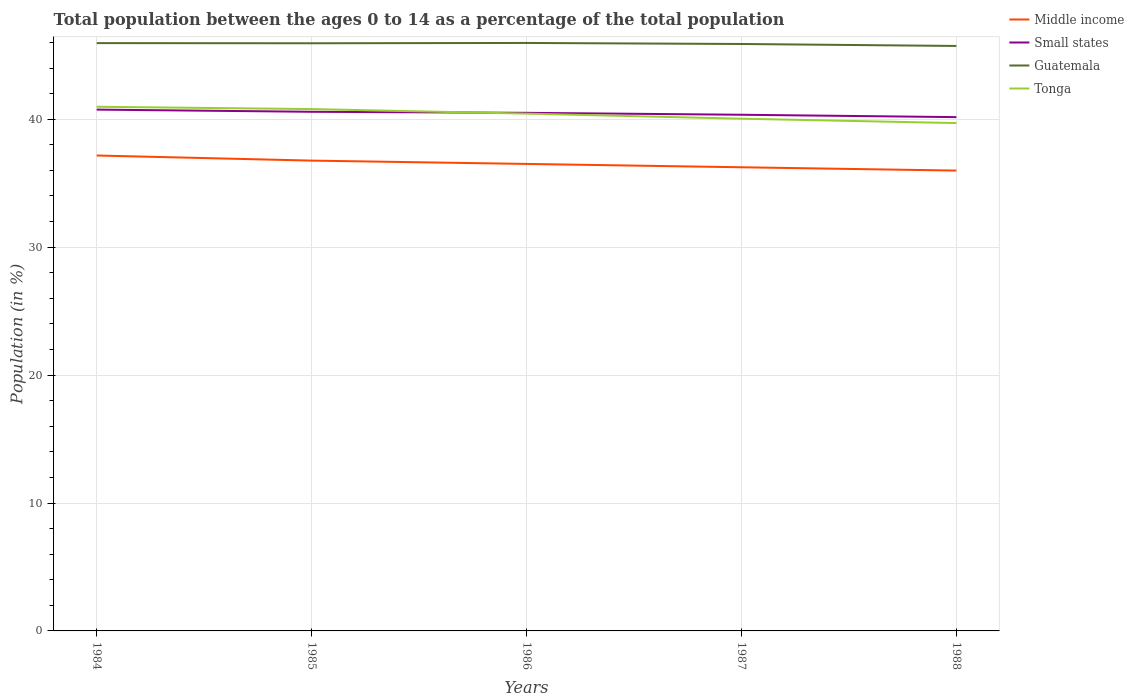Does the line corresponding to Middle income intersect with the line corresponding to Small states?
Your answer should be very brief. No. Is the number of lines equal to the number of legend labels?
Offer a very short reply. Yes. Across all years, what is the maximum percentage of the population ages 0 to 14 in Tonga?
Your response must be concise. 39.7. In which year was the percentage of the population ages 0 to 14 in Guatemala maximum?
Offer a terse response. 1988. What is the total percentage of the population ages 0 to 14 in Small states in the graph?
Give a very brief answer. 0.23. What is the difference between the highest and the second highest percentage of the population ages 0 to 14 in Small states?
Keep it short and to the point. 0.59. Is the percentage of the population ages 0 to 14 in Tonga strictly greater than the percentage of the population ages 0 to 14 in Small states over the years?
Your answer should be very brief. No. What is the difference between two consecutive major ticks on the Y-axis?
Offer a very short reply. 10. Does the graph contain any zero values?
Keep it short and to the point. No. Where does the legend appear in the graph?
Offer a very short reply. Top right. How are the legend labels stacked?
Your answer should be very brief. Vertical. What is the title of the graph?
Offer a terse response. Total population between the ages 0 to 14 as a percentage of the total population. Does "Malawi" appear as one of the legend labels in the graph?
Keep it short and to the point. No. What is the label or title of the X-axis?
Make the answer very short. Years. What is the Population (in %) in Middle income in 1984?
Your answer should be very brief. 37.17. What is the Population (in %) in Small states in 1984?
Your response must be concise. 40.75. What is the Population (in %) of Guatemala in 1984?
Your answer should be very brief. 45.95. What is the Population (in %) of Tonga in 1984?
Give a very brief answer. 40.98. What is the Population (in %) in Middle income in 1985?
Give a very brief answer. 36.77. What is the Population (in %) of Small states in 1985?
Keep it short and to the point. 40.58. What is the Population (in %) of Guatemala in 1985?
Your answer should be compact. 45.94. What is the Population (in %) of Tonga in 1985?
Your response must be concise. 40.79. What is the Population (in %) in Middle income in 1986?
Your response must be concise. 36.51. What is the Population (in %) of Small states in 1986?
Offer a very short reply. 40.5. What is the Population (in %) in Guatemala in 1986?
Provide a succinct answer. 45.96. What is the Population (in %) of Tonga in 1986?
Give a very brief answer. 40.44. What is the Population (in %) in Middle income in 1987?
Give a very brief answer. 36.25. What is the Population (in %) of Small states in 1987?
Your answer should be compact. 40.35. What is the Population (in %) in Guatemala in 1987?
Provide a short and direct response. 45.88. What is the Population (in %) of Tonga in 1987?
Provide a succinct answer. 40.04. What is the Population (in %) of Middle income in 1988?
Offer a terse response. 35.99. What is the Population (in %) in Small states in 1988?
Ensure brevity in your answer.  40.17. What is the Population (in %) in Guatemala in 1988?
Provide a succinct answer. 45.73. What is the Population (in %) of Tonga in 1988?
Give a very brief answer. 39.7. Across all years, what is the maximum Population (in %) in Middle income?
Provide a short and direct response. 37.17. Across all years, what is the maximum Population (in %) of Small states?
Your answer should be very brief. 40.75. Across all years, what is the maximum Population (in %) of Guatemala?
Offer a terse response. 45.96. Across all years, what is the maximum Population (in %) of Tonga?
Give a very brief answer. 40.98. Across all years, what is the minimum Population (in %) in Middle income?
Offer a very short reply. 35.99. Across all years, what is the minimum Population (in %) of Small states?
Give a very brief answer. 40.17. Across all years, what is the minimum Population (in %) of Guatemala?
Your answer should be very brief. 45.73. Across all years, what is the minimum Population (in %) of Tonga?
Give a very brief answer. 39.7. What is the total Population (in %) in Middle income in the graph?
Keep it short and to the point. 182.67. What is the total Population (in %) in Small states in the graph?
Your answer should be very brief. 202.36. What is the total Population (in %) in Guatemala in the graph?
Make the answer very short. 229.47. What is the total Population (in %) in Tonga in the graph?
Ensure brevity in your answer.  201.95. What is the difference between the Population (in %) in Middle income in 1984 and that in 1985?
Offer a very short reply. 0.4. What is the difference between the Population (in %) in Small states in 1984 and that in 1985?
Your answer should be compact. 0.17. What is the difference between the Population (in %) of Guatemala in 1984 and that in 1985?
Ensure brevity in your answer.  0.01. What is the difference between the Population (in %) in Tonga in 1984 and that in 1985?
Your answer should be very brief. 0.18. What is the difference between the Population (in %) of Middle income in 1984 and that in 1986?
Your response must be concise. 0.66. What is the difference between the Population (in %) in Small states in 1984 and that in 1986?
Provide a succinct answer. 0.25. What is the difference between the Population (in %) in Guatemala in 1984 and that in 1986?
Your response must be concise. -0.01. What is the difference between the Population (in %) in Tonga in 1984 and that in 1986?
Ensure brevity in your answer.  0.54. What is the difference between the Population (in %) in Middle income in 1984 and that in 1987?
Provide a short and direct response. 0.92. What is the difference between the Population (in %) of Small states in 1984 and that in 1987?
Your answer should be very brief. 0.4. What is the difference between the Population (in %) of Guatemala in 1984 and that in 1987?
Make the answer very short. 0.07. What is the difference between the Population (in %) of Tonga in 1984 and that in 1987?
Provide a short and direct response. 0.93. What is the difference between the Population (in %) in Middle income in 1984 and that in 1988?
Your answer should be very brief. 1.18. What is the difference between the Population (in %) of Small states in 1984 and that in 1988?
Offer a very short reply. 0.59. What is the difference between the Population (in %) in Guatemala in 1984 and that in 1988?
Provide a succinct answer. 0.22. What is the difference between the Population (in %) of Tonga in 1984 and that in 1988?
Give a very brief answer. 1.28. What is the difference between the Population (in %) of Middle income in 1985 and that in 1986?
Ensure brevity in your answer.  0.26. What is the difference between the Population (in %) of Small states in 1985 and that in 1986?
Keep it short and to the point. 0.08. What is the difference between the Population (in %) of Guatemala in 1985 and that in 1986?
Make the answer very short. -0.02. What is the difference between the Population (in %) of Tonga in 1985 and that in 1986?
Ensure brevity in your answer.  0.36. What is the difference between the Population (in %) in Middle income in 1985 and that in 1987?
Your answer should be compact. 0.52. What is the difference between the Population (in %) of Small states in 1985 and that in 1987?
Keep it short and to the point. 0.23. What is the difference between the Population (in %) of Guatemala in 1985 and that in 1987?
Make the answer very short. 0.06. What is the difference between the Population (in %) in Tonga in 1985 and that in 1987?
Provide a short and direct response. 0.75. What is the difference between the Population (in %) in Middle income in 1985 and that in 1988?
Provide a succinct answer. 0.78. What is the difference between the Population (in %) in Small states in 1985 and that in 1988?
Offer a very short reply. 0.42. What is the difference between the Population (in %) in Guatemala in 1985 and that in 1988?
Offer a very short reply. 0.21. What is the difference between the Population (in %) of Tonga in 1985 and that in 1988?
Give a very brief answer. 1.09. What is the difference between the Population (in %) in Middle income in 1986 and that in 1987?
Give a very brief answer. 0.26. What is the difference between the Population (in %) in Small states in 1986 and that in 1987?
Your response must be concise. 0.15. What is the difference between the Population (in %) of Guatemala in 1986 and that in 1987?
Make the answer very short. 0.08. What is the difference between the Population (in %) in Tonga in 1986 and that in 1987?
Give a very brief answer. 0.4. What is the difference between the Population (in %) in Middle income in 1986 and that in 1988?
Keep it short and to the point. 0.52. What is the difference between the Population (in %) in Small states in 1986 and that in 1988?
Offer a very short reply. 0.34. What is the difference between the Population (in %) in Guatemala in 1986 and that in 1988?
Keep it short and to the point. 0.23. What is the difference between the Population (in %) of Tonga in 1986 and that in 1988?
Offer a very short reply. 0.74. What is the difference between the Population (in %) in Middle income in 1987 and that in 1988?
Your answer should be very brief. 0.26. What is the difference between the Population (in %) in Small states in 1987 and that in 1988?
Offer a terse response. 0.19. What is the difference between the Population (in %) of Guatemala in 1987 and that in 1988?
Your answer should be compact. 0.15. What is the difference between the Population (in %) of Tonga in 1987 and that in 1988?
Keep it short and to the point. 0.34. What is the difference between the Population (in %) of Middle income in 1984 and the Population (in %) of Small states in 1985?
Your response must be concise. -3.42. What is the difference between the Population (in %) in Middle income in 1984 and the Population (in %) in Guatemala in 1985?
Make the answer very short. -8.77. What is the difference between the Population (in %) in Middle income in 1984 and the Population (in %) in Tonga in 1985?
Give a very brief answer. -3.63. What is the difference between the Population (in %) in Small states in 1984 and the Population (in %) in Guatemala in 1985?
Your answer should be compact. -5.19. What is the difference between the Population (in %) of Small states in 1984 and the Population (in %) of Tonga in 1985?
Give a very brief answer. -0.04. What is the difference between the Population (in %) of Guatemala in 1984 and the Population (in %) of Tonga in 1985?
Make the answer very short. 5.16. What is the difference between the Population (in %) of Middle income in 1984 and the Population (in %) of Small states in 1986?
Your response must be concise. -3.34. What is the difference between the Population (in %) in Middle income in 1984 and the Population (in %) in Guatemala in 1986?
Provide a short and direct response. -8.8. What is the difference between the Population (in %) in Middle income in 1984 and the Population (in %) in Tonga in 1986?
Provide a short and direct response. -3.27. What is the difference between the Population (in %) in Small states in 1984 and the Population (in %) in Guatemala in 1986?
Your answer should be compact. -5.21. What is the difference between the Population (in %) of Small states in 1984 and the Population (in %) of Tonga in 1986?
Ensure brevity in your answer.  0.31. What is the difference between the Population (in %) of Guatemala in 1984 and the Population (in %) of Tonga in 1986?
Make the answer very short. 5.51. What is the difference between the Population (in %) in Middle income in 1984 and the Population (in %) in Small states in 1987?
Your answer should be very brief. -3.19. What is the difference between the Population (in %) of Middle income in 1984 and the Population (in %) of Guatemala in 1987?
Your response must be concise. -8.72. What is the difference between the Population (in %) of Middle income in 1984 and the Population (in %) of Tonga in 1987?
Offer a terse response. -2.88. What is the difference between the Population (in %) of Small states in 1984 and the Population (in %) of Guatemala in 1987?
Your answer should be very brief. -5.13. What is the difference between the Population (in %) of Small states in 1984 and the Population (in %) of Tonga in 1987?
Ensure brevity in your answer.  0.71. What is the difference between the Population (in %) in Guatemala in 1984 and the Population (in %) in Tonga in 1987?
Ensure brevity in your answer.  5.91. What is the difference between the Population (in %) of Middle income in 1984 and the Population (in %) of Small states in 1988?
Offer a terse response. -3. What is the difference between the Population (in %) of Middle income in 1984 and the Population (in %) of Guatemala in 1988?
Your response must be concise. -8.56. What is the difference between the Population (in %) in Middle income in 1984 and the Population (in %) in Tonga in 1988?
Your answer should be compact. -2.53. What is the difference between the Population (in %) of Small states in 1984 and the Population (in %) of Guatemala in 1988?
Provide a short and direct response. -4.98. What is the difference between the Population (in %) in Small states in 1984 and the Population (in %) in Tonga in 1988?
Your answer should be compact. 1.05. What is the difference between the Population (in %) in Guatemala in 1984 and the Population (in %) in Tonga in 1988?
Offer a very short reply. 6.25. What is the difference between the Population (in %) of Middle income in 1985 and the Population (in %) of Small states in 1986?
Give a very brief answer. -3.74. What is the difference between the Population (in %) in Middle income in 1985 and the Population (in %) in Guatemala in 1986?
Offer a very short reply. -9.2. What is the difference between the Population (in %) in Middle income in 1985 and the Population (in %) in Tonga in 1986?
Provide a short and direct response. -3.67. What is the difference between the Population (in %) of Small states in 1985 and the Population (in %) of Guatemala in 1986?
Keep it short and to the point. -5.38. What is the difference between the Population (in %) of Small states in 1985 and the Population (in %) of Tonga in 1986?
Give a very brief answer. 0.14. What is the difference between the Population (in %) in Guatemala in 1985 and the Population (in %) in Tonga in 1986?
Your response must be concise. 5.5. What is the difference between the Population (in %) in Middle income in 1985 and the Population (in %) in Small states in 1987?
Make the answer very short. -3.59. What is the difference between the Population (in %) in Middle income in 1985 and the Population (in %) in Guatemala in 1987?
Your response must be concise. -9.12. What is the difference between the Population (in %) of Middle income in 1985 and the Population (in %) of Tonga in 1987?
Offer a very short reply. -3.28. What is the difference between the Population (in %) in Small states in 1985 and the Population (in %) in Guatemala in 1987?
Ensure brevity in your answer.  -5.3. What is the difference between the Population (in %) in Small states in 1985 and the Population (in %) in Tonga in 1987?
Give a very brief answer. 0.54. What is the difference between the Population (in %) in Guatemala in 1985 and the Population (in %) in Tonga in 1987?
Provide a succinct answer. 5.9. What is the difference between the Population (in %) of Middle income in 1985 and the Population (in %) of Small states in 1988?
Keep it short and to the point. -3.4. What is the difference between the Population (in %) in Middle income in 1985 and the Population (in %) in Guatemala in 1988?
Make the answer very short. -8.96. What is the difference between the Population (in %) of Middle income in 1985 and the Population (in %) of Tonga in 1988?
Offer a terse response. -2.93. What is the difference between the Population (in %) in Small states in 1985 and the Population (in %) in Guatemala in 1988?
Keep it short and to the point. -5.15. What is the difference between the Population (in %) in Small states in 1985 and the Population (in %) in Tonga in 1988?
Offer a very short reply. 0.88. What is the difference between the Population (in %) in Guatemala in 1985 and the Population (in %) in Tonga in 1988?
Offer a very short reply. 6.24. What is the difference between the Population (in %) in Middle income in 1986 and the Population (in %) in Small states in 1987?
Provide a succinct answer. -3.84. What is the difference between the Population (in %) of Middle income in 1986 and the Population (in %) of Guatemala in 1987?
Ensure brevity in your answer.  -9.38. What is the difference between the Population (in %) in Middle income in 1986 and the Population (in %) in Tonga in 1987?
Keep it short and to the point. -3.54. What is the difference between the Population (in %) of Small states in 1986 and the Population (in %) of Guatemala in 1987?
Give a very brief answer. -5.38. What is the difference between the Population (in %) of Small states in 1986 and the Population (in %) of Tonga in 1987?
Your answer should be very brief. 0.46. What is the difference between the Population (in %) of Guatemala in 1986 and the Population (in %) of Tonga in 1987?
Your response must be concise. 5.92. What is the difference between the Population (in %) in Middle income in 1986 and the Population (in %) in Small states in 1988?
Offer a terse response. -3.66. What is the difference between the Population (in %) of Middle income in 1986 and the Population (in %) of Guatemala in 1988?
Offer a very short reply. -9.22. What is the difference between the Population (in %) of Middle income in 1986 and the Population (in %) of Tonga in 1988?
Offer a terse response. -3.19. What is the difference between the Population (in %) in Small states in 1986 and the Population (in %) in Guatemala in 1988?
Give a very brief answer. -5.23. What is the difference between the Population (in %) of Small states in 1986 and the Population (in %) of Tonga in 1988?
Keep it short and to the point. 0.8. What is the difference between the Population (in %) in Guatemala in 1986 and the Population (in %) in Tonga in 1988?
Give a very brief answer. 6.26. What is the difference between the Population (in %) in Middle income in 1987 and the Population (in %) in Small states in 1988?
Keep it short and to the point. -3.92. What is the difference between the Population (in %) in Middle income in 1987 and the Population (in %) in Guatemala in 1988?
Keep it short and to the point. -9.48. What is the difference between the Population (in %) of Middle income in 1987 and the Population (in %) of Tonga in 1988?
Keep it short and to the point. -3.45. What is the difference between the Population (in %) of Small states in 1987 and the Population (in %) of Guatemala in 1988?
Your answer should be very brief. -5.38. What is the difference between the Population (in %) in Small states in 1987 and the Population (in %) in Tonga in 1988?
Keep it short and to the point. 0.65. What is the difference between the Population (in %) in Guatemala in 1987 and the Population (in %) in Tonga in 1988?
Provide a short and direct response. 6.18. What is the average Population (in %) in Middle income per year?
Offer a very short reply. 36.53. What is the average Population (in %) of Small states per year?
Offer a very short reply. 40.47. What is the average Population (in %) of Guatemala per year?
Offer a very short reply. 45.89. What is the average Population (in %) in Tonga per year?
Offer a terse response. 40.39. In the year 1984, what is the difference between the Population (in %) of Middle income and Population (in %) of Small states?
Your answer should be very brief. -3.59. In the year 1984, what is the difference between the Population (in %) in Middle income and Population (in %) in Guatemala?
Your answer should be compact. -8.79. In the year 1984, what is the difference between the Population (in %) of Middle income and Population (in %) of Tonga?
Your response must be concise. -3.81. In the year 1984, what is the difference between the Population (in %) of Small states and Population (in %) of Guatemala?
Provide a succinct answer. -5.2. In the year 1984, what is the difference between the Population (in %) in Small states and Population (in %) in Tonga?
Ensure brevity in your answer.  -0.22. In the year 1984, what is the difference between the Population (in %) in Guatemala and Population (in %) in Tonga?
Keep it short and to the point. 4.97. In the year 1985, what is the difference between the Population (in %) of Middle income and Population (in %) of Small states?
Offer a terse response. -3.82. In the year 1985, what is the difference between the Population (in %) in Middle income and Population (in %) in Guatemala?
Offer a very short reply. -9.17. In the year 1985, what is the difference between the Population (in %) of Middle income and Population (in %) of Tonga?
Give a very brief answer. -4.03. In the year 1985, what is the difference between the Population (in %) of Small states and Population (in %) of Guatemala?
Make the answer very short. -5.36. In the year 1985, what is the difference between the Population (in %) in Small states and Population (in %) in Tonga?
Offer a very short reply. -0.21. In the year 1985, what is the difference between the Population (in %) of Guatemala and Population (in %) of Tonga?
Give a very brief answer. 5.14. In the year 1986, what is the difference between the Population (in %) of Middle income and Population (in %) of Small states?
Offer a very short reply. -3.99. In the year 1986, what is the difference between the Population (in %) in Middle income and Population (in %) in Guatemala?
Your answer should be compact. -9.46. In the year 1986, what is the difference between the Population (in %) of Middle income and Population (in %) of Tonga?
Give a very brief answer. -3.93. In the year 1986, what is the difference between the Population (in %) in Small states and Population (in %) in Guatemala?
Your answer should be compact. -5.46. In the year 1986, what is the difference between the Population (in %) in Small states and Population (in %) in Tonga?
Offer a very short reply. 0.06. In the year 1986, what is the difference between the Population (in %) in Guatemala and Population (in %) in Tonga?
Keep it short and to the point. 5.53. In the year 1987, what is the difference between the Population (in %) in Middle income and Population (in %) in Small states?
Provide a succinct answer. -4.11. In the year 1987, what is the difference between the Population (in %) in Middle income and Population (in %) in Guatemala?
Keep it short and to the point. -9.64. In the year 1987, what is the difference between the Population (in %) of Middle income and Population (in %) of Tonga?
Keep it short and to the point. -3.8. In the year 1987, what is the difference between the Population (in %) of Small states and Population (in %) of Guatemala?
Your response must be concise. -5.53. In the year 1987, what is the difference between the Population (in %) in Small states and Population (in %) in Tonga?
Ensure brevity in your answer.  0.31. In the year 1987, what is the difference between the Population (in %) of Guatemala and Population (in %) of Tonga?
Give a very brief answer. 5.84. In the year 1988, what is the difference between the Population (in %) in Middle income and Population (in %) in Small states?
Offer a terse response. -4.18. In the year 1988, what is the difference between the Population (in %) in Middle income and Population (in %) in Guatemala?
Provide a short and direct response. -9.74. In the year 1988, what is the difference between the Population (in %) in Middle income and Population (in %) in Tonga?
Your answer should be very brief. -3.71. In the year 1988, what is the difference between the Population (in %) in Small states and Population (in %) in Guatemala?
Your answer should be compact. -5.56. In the year 1988, what is the difference between the Population (in %) in Small states and Population (in %) in Tonga?
Your answer should be compact. 0.47. In the year 1988, what is the difference between the Population (in %) in Guatemala and Population (in %) in Tonga?
Offer a terse response. 6.03. What is the ratio of the Population (in %) of Middle income in 1984 to that in 1985?
Give a very brief answer. 1.01. What is the ratio of the Population (in %) in Tonga in 1984 to that in 1985?
Keep it short and to the point. 1. What is the ratio of the Population (in %) in Middle income in 1984 to that in 1986?
Ensure brevity in your answer.  1.02. What is the ratio of the Population (in %) in Small states in 1984 to that in 1986?
Provide a succinct answer. 1.01. What is the ratio of the Population (in %) of Guatemala in 1984 to that in 1986?
Your answer should be compact. 1. What is the ratio of the Population (in %) in Tonga in 1984 to that in 1986?
Ensure brevity in your answer.  1.01. What is the ratio of the Population (in %) in Middle income in 1984 to that in 1987?
Ensure brevity in your answer.  1.03. What is the ratio of the Population (in %) of Tonga in 1984 to that in 1987?
Your response must be concise. 1.02. What is the ratio of the Population (in %) of Middle income in 1984 to that in 1988?
Keep it short and to the point. 1.03. What is the ratio of the Population (in %) of Small states in 1984 to that in 1988?
Provide a short and direct response. 1.01. What is the ratio of the Population (in %) in Guatemala in 1984 to that in 1988?
Offer a terse response. 1. What is the ratio of the Population (in %) in Tonga in 1984 to that in 1988?
Provide a short and direct response. 1.03. What is the ratio of the Population (in %) of Middle income in 1985 to that in 1986?
Your answer should be very brief. 1.01. What is the ratio of the Population (in %) in Guatemala in 1985 to that in 1986?
Offer a terse response. 1. What is the ratio of the Population (in %) in Tonga in 1985 to that in 1986?
Provide a succinct answer. 1.01. What is the ratio of the Population (in %) in Middle income in 1985 to that in 1987?
Your answer should be very brief. 1.01. What is the ratio of the Population (in %) in Guatemala in 1985 to that in 1987?
Keep it short and to the point. 1. What is the ratio of the Population (in %) in Tonga in 1985 to that in 1987?
Provide a succinct answer. 1.02. What is the ratio of the Population (in %) in Middle income in 1985 to that in 1988?
Give a very brief answer. 1.02. What is the ratio of the Population (in %) in Small states in 1985 to that in 1988?
Ensure brevity in your answer.  1.01. What is the ratio of the Population (in %) of Guatemala in 1985 to that in 1988?
Your answer should be compact. 1. What is the ratio of the Population (in %) of Tonga in 1985 to that in 1988?
Offer a very short reply. 1.03. What is the ratio of the Population (in %) in Guatemala in 1986 to that in 1987?
Offer a terse response. 1. What is the ratio of the Population (in %) of Tonga in 1986 to that in 1987?
Offer a terse response. 1.01. What is the ratio of the Population (in %) in Middle income in 1986 to that in 1988?
Provide a succinct answer. 1.01. What is the ratio of the Population (in %) in Small states in 1986 to that in 1988?
Your answer should be compact. 1.01. What is the ratio of the Population (in %) of Tonga in 1986 to that in 1988?
Make the answer very short. 1.02. What is the ratio of the Population (in %) in Middle income in 1987 to that in 1988?
Your answer should be very brief. 1.01. What is the ratio of the Population (in %) in Small states in 1987 to that in 1988?
Give a very brief answer. 1. What is the ratio of the Population (in %) of Guatemala in 1987 to that in 1988?
Provide a short and direct response. 1. What is the ratio of the Population (in %) in Tonga in 1987 to that in 1988?
Offer a terse response. 1.01. What is the difference between the highest and the second highest Population (in %) of Middle income?
Ensure brevity in your answer.  0.4. What is the difference between the highest and the second highest Population (in %) of Small states?
Your answer should be very brief. 0.17. What is the difference between the highest and the second highest Population (in %) in Guatemala?
Make the answer very short. 0.01. What is the difference between the highest and the second highest Population (in %) of Tonga?
Offer a terse response. 0.18. What is the difference between the highest and the lowest Population (in %) in Middle income?
Offer a terse response. 1.18. What is the difference between the highest and the lowest Population (in %) in Small states?
Offer a very short reply. 0.59. What is the difference between the highest and the lowest Population (in %) of Guatemala?
Provide a short and direct response. 0.23. What is the difference between the highest and the lowest Population (in %) in Tonga?
Keep it short and to the point. 1.28. 